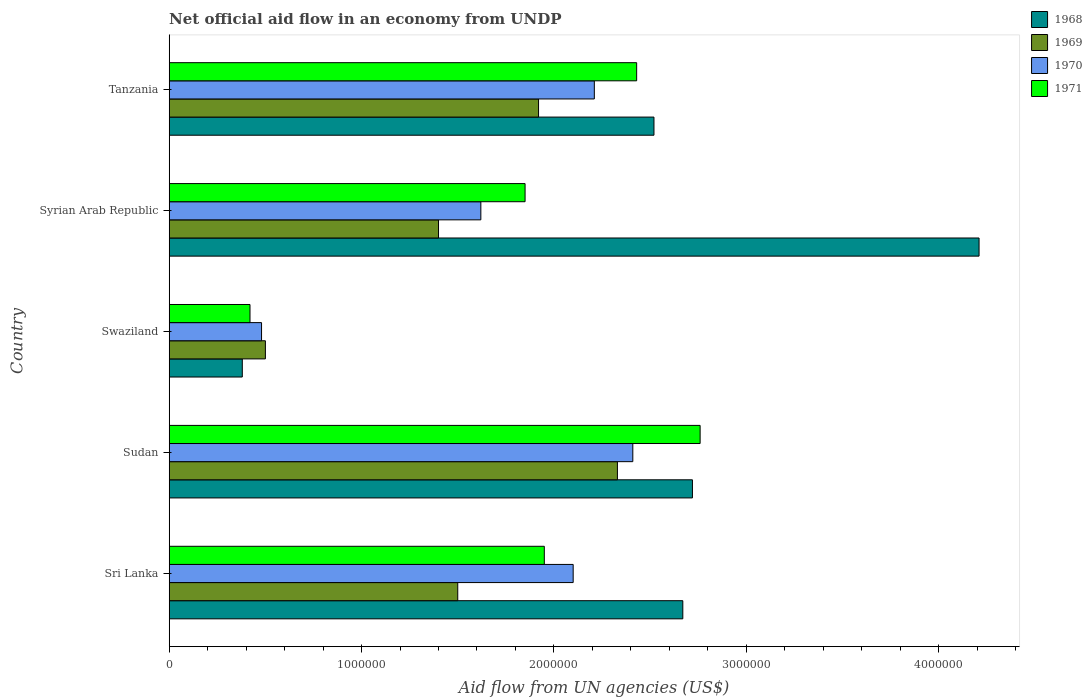How many different coloured bars are there?
Provide a short and direct response. 4. How many groups of bars are there?
Your answer should be very brief. 5. Are the number of bars per tick equal to the number of legend labels?
Offer a very short reply. Yes. Are the number of bars on each tick of the Y-axis equal?
Your answer should be compact. Yes. How many bars are there on the 1st tick from the top?
Provide a succinct answer. 4. What is the label of the 4th group of bars from the top?
Give a very brief answer. Sudan. What is the net official aid flow in 1970 in Tanzania?
Your response must be concise. 2.21e+06. Across all countries, what is the maximum net official aid flow in 1968?
Ensure brevity in your answer.  4.21e+06. Across all countries, what is the minimum net official aid flow in 1969?
Keep it short and to the point. 5.00e+05. In which country was the net official aid flow in 1970 maximum?
Your answer should be compact. Sudan. In which country was the net official aid flow in 1969 minimum?
Provide a succinct answer. Swaziland. What is the total net official aid flow in 1969 in the graph?
Ensure brevity in your answer.  7.65e+06. What is the difference between the net official aid flow in 1971 in Syrian Arab Republic and that in Tanzania?
Ensure brevity in your answer.  -5.80e+05. What is the difference between the net official aid flow in 1970 in Tanzania and the net official aid flow in 1971 in Swaziland?
Keep it short and to the point. 1.79e+06. What is the average net official aid flow in 1970 per country?
Your answer should be compact. 1.76e+06. What is the difference between the net official aid flow in 1968 and net official aid flow in 1969 in Syrian Arab Republic?
Offer a very short reply. 2.81e+06. In how many countries, is the net official aid flow in 1968 greater than 1600000 US$?
Make the answer very short. 4. What is the ratio of the net official aid flow in 1968 in Sri Lanka to that in Syrian Arab Republic?
Your response must be concise. 0.63. Is the net official aid flow in 1969 in Sri Lanka less than that in Swaziland?
Provide a short and direct response. No. Is the difference between the net official aid flow in 1968 in Sudan and Tanzania greater than the difference between the net official aid flow in 1969 in Sudan and Tanzania?
Provide a short and direct response. No. What is the difference between the highest and the second highest net official aid flow in 1970?
Give a very brief answer. 2.00e+05. What is the difference between the highest and the lowest net official aid flow in 1969?
Offer a very short reply. 1.83e+06. In how many countries, is the net official aid flow in 1971 greater than the average net official aid flow in 1971 taken over all countries?
Provide a succinct answer. 3. Is the sum of the net official aid flow in 1969 in Sri Lanka and Swaziland greater than the maximum net official aid flow in 1971 across all countries?
Offer a terse response. No. Is it the case that in every country, the sum of the net official aid flow in 1971 and net official aid flow in 1969 is greater than the sum of net official aid flow in 1968 and net official aid flow in 1970?
Your response must be concise. No. What does the 1st bar from the bottom in Sri Lanka represents?
Provide a short and direct response. 1968. How many countries are there in the graph?
Provide a short and direct response. 5. What is the difference between two consecutive major ticks on the X-axis?
Offer a terse response. 1.00e+06. Does the graph contain any zero values?
Provide a short and direct response. No. How many legend labels are there?
Your answer should be compact. 4. What is the title of the graph?
Give a very brief answer. Net official aid flow in an economy from UNDP. Does "1978" appear as one of the legend labels in the graph?
Provide a succinct answer. No. What is the label or title of the X-axis?
Offer a terse response. Aid flow from UN agencies (US$). What is the Aid flow from UN agencies (US$) in 1968 in Sri Lanka?
Give a very brief answer. 2.67e+06. What is the Aid flow from UN agencies (US$) of 1969 in Sri Lanka?
Offer a very short reply. 1.50e+06. What is the Aid flow from UN agencies (US$) in 1970 in Sri Lanka?
Offer a terse response. 2.10e+06. What is the Aid flow from UN agencies (US$) of 1971 in Sri Lanka?
Make the answer very short. 1.95e+06. What is the Aid flow from UN agencies (US$) in 1968 in Sudan?
Give a very brief answer. 2.72e+06. What is the Aid flow from UN agencies (US$) in 1969 in Sudan?
Your answer should be very brief. 2.33e+06. What is the Aid flow from UN agencies (US$) in 1970 in Sudan?
Ensure brevity in your answer.  2.41e+06. What is the Aid flow from UN agencies (US$) in 1971 in Sudan?
Keep it short and to the point. 2.76e+06. What is the Aid flow from UN agencies (US$) in 1968 in Swaziland?
Provide a short and direct response. 3.80e+05. What is the Aid flow from UN agencies (US$) of 1969 in Swaziland?
Your response must be concise. 5.00e+05. What is the Aid flow from UN agencies (US$) of 1970 in Swaziland?
Your response must be concise. 4.80e+05. What is the Aid flow from UN agencies (US$) of 1971 in Swaziland?
Provide a short and direct response. 4.20e+05. What is the Aid flow from UN agencies (US$) of 1968 in Syrian Arab Republic?
Offer a terse response. 4.21e+06. What is the Aid flow from UN agencies (US$) in 1969 in Syrian Arab Republic?
Your answer should be very brief. 1.40e+06. What is the Aid flow from UN agencies (US$) of 1970 in Syrian Arab Republic?
Make the answer very short. 1.62e+06. What is the Aid flow from UN agencies (US$) of 1971 in Syrian Arab Republic?
Provide a succinct answer. 1.85e+06. What is the Aid flow from UN agencies (US$) of 1968 in Tanzania?
Offer a very short reply. 2.52e+06. What is the Aid flow from UN agencies (US$) of 1969 in Tanzania?
Your answer should be compact. 1.92e+06. What is the Aid flow from UN agencies (US$) in 1970 in Tanzania?
Provide a short and direct response. 2.21e+06. What is the Aid flow from UN agencies (US$) in 1971 in Tanzania?
Your response must be concise. 2.43e+06. Across all countries, what is the maximum Aid flow from UN agencies (US$) in 1968?
Give a very brief answer. 4.21e+06. Across all countries, what is the maximum Aid flow from UN agencies (US$) in 1969?
Ensure brevity in your answer.  2.33e+06. Across all countries, what is the maximum Aid flow from UN agencies (US$) of 1970?
Your answer should be compact. 2.41e+06. Across all countries, what is the maximum Aid flow from UN agencies (US$) in 1971?
Your answer should be compact. 2.76e+06. Across all countries, what is the minimum Aid flow from UN agencies (US$) of 1968?
Provide a short and direct response. 3.80e+05. Across all countries, what is the minimum Aid flow from UN agencies (US$) of 1970?
Ensure brevity in your answer.  4.80e+05. Across all countries, what is the minimum Aid flow from UN agencies (US$) in 1971?
Offer a terse response. 4.20e+05. What is the total Aid flow from UN agencies (US$) of 1968 in the graph?
Make the answer very short. 1.25e+07. What is the total Aid flow from UN agencies (US$) in 1969 in the graph?
Offer a very short reply. 7.65e+06. What is the total Aid flow from UN agencies (US$) in 1970 in the graph?
Your response must be concise. 8.82e+06. What is the total Aid flow from UN agencies (US$) of 1971 in the graph?
Offer a very short reply. 9.41e+06. What is the difference between the Aid flow from UN agencies (US$) in 1969 in Sri Lanka and that in Sudan?
Your response must be concise. -8.30e+05. What is the difference between the Aid flow from UN agencies (US$) of 1970 in Sri Lanka and that in Sudan?
Ensure brevity in your answer.  -3.10e+05. What is the difference between the Aid flow from UN agencies (US$) of 1971 in Sri Lanka and that in Sudan?
Give a very brief answer. -8.10e+05. What is the difference between the Aid flow from UN agencies (US$) in 1968 in Sri Lanka and that in Swaziland?
Give a very brief answer. 2.29e+06. What is the difference between the Aid flow from UN agencies (US$) in 1969 in Sri Lanka and that in Swaziland?
Your answer should be compact. 1.00e+06. What is the difference between the Aid flow from UN agencies (US$) in 1970 in Sri Lanka and that in Swaziland?
Provide a short and direct response. 1.62e+06. What is the difference between the Aid flow from UN agencies (US$) in 1971 in Sri Lanka and that in Swaziland?
Ensure brevity in your answer.  1.53e+06. What is the difference between the Aid flow from UN agencies (US$) of 1968 in Sri Lanka and that in Syrian Arab Republic?
Keep it short and to the point. -1.54e+06. What is the difference between the Aid flow from UN agencies (US$) in 1971 in Sri Lanka and that in Syrian Arab Republic?
Your answer should be very brief. 1.00e+05. What is the difference between the Aid flow from UN agencies (US$) in 1969 in Sri Lanka and that in Tanzania?
Offer a very short reply. -4.20e+05. What is the difference between the Aid flow from UN agencies (US$) of 1971 in Sri Lanka and that in Tanzania?
Provide a short and direct response. -4.80e+05. What is the difference between the Aid flow from UN agencies (US$) of 1968 in Sudan and that in Swaziland?
Your answer should be very brief. 2.34e+06. What is the difference between the Aid flow from UN agencies (US$) of 1969 in Sudan and that in Swaziland?
Your response must be concise. 1.83e+06. What is the difference between the Aid flow from UN agencies (US$) of 1970 in Sudan and that in Swaziland?
Provide a short and direct response. 1.93e+06. What is the difference between the Aid flow from UN agencies (US$) of 1971 in Sudan and that in Swaziland?
Your response must be concise. 2.34e+06. What is the difference between the Aid flow from UN agencies (US$) in 1968 in Sudan and that in Syrian Arab Republic?
Provide a succinct answer. -1.49e+06. What is the difference between the Aid flow from UN agencies (US$) of 1969 in Sudan and that in Syrian Arab Republic?
Your answer should be very brief. 9.30e+05. What is the difference between the Aid flow from UN agencies (US$) of 1970 in Sudan and that in Syrian Arab Republic?
Offer a terse response. 7.90e+05. What is the difference between the Aid flow from UN agencies (US$) of 1971 in Sudan and that in Syrian Arab Republic?
Your answer should be very brief. 9.10e+05. What is the difference between the Aid flow from UN agencies (US$) of 1968 in Sudan and that in Tanzania?
Provide a short and direct response. 2.00e+05. What is the difference between the Aid flow from UN agencies (US$) in 1971 in Sudan and that in Tanzania?
Offer a terse response. 3.30e+05. What is the difference between the Aid flow from UN agencies (US$) in 1968 in Swaziland and that in Syrian Arab Republic?
Provide a short and direct response. -3.83e+06. What is the difference between the Aid flow from UN agencies (US$) in 1969 in Swaziland and that in Syrian Arab Republic?
Your answer should be compact. -9.00e+05. What is the difference between the Aid flow from UN agencies (US$) of 1970 in Swaziland and that in Syrian Arab Republic?
Ensure brevity in your answer.  -1.14e+06. What is the difference between the Aid flow from UN agencies (US$) in 1971 in Swaziland and that in Syrian Arab Republic?
Your response must be concise. -1.43e+06. What is the difference between the Aid flow from UN agencies (US$) in 1968 in Swaziland and that in Tanzania?
Ensure brevity in your answer.  -2.14e+06. What is the difference between the Aid flow from UN agencies (US$) in 1969 in Swaziland and that in Tanzania?
Keep it short and to the point. -1.42e+06. What is the difference between the Aid flow from UN agencies (US$) in 1970 in Swaziland and that in Tanzania?
Your answer should be compact. -1.73e+06. What is the difference between the Aid flow from UN agencies (US$) of 1971 in Swaziland and that in Tanzania?
Ensure brevity in your answer.  -2.01e+06. What is the difference between the Aid flow from UN agencies (US$) in 1968 in Syrian Arab Republic and that in Tanzania?
Your answer should be compact. 1.69e+06. What is the difference between the Aid flow from UN agencies (US$) of 1969 in Syrian Arab Republic and that in Tanzania?
Offer a terse response. -5.20e+05. What is the difference between the Aid flow from UN agencies (US$) in 1970 in Syrian Arab Republic and that in Tanzania?
Your answer should be very brief. -5.90e+05. What is the difference between the Aid flow from UN agencies (US$) of 1971 in Syrian Arab Republic and that in Tanzania?
Your answer should be very brief. -5.80e+05. What is the difference between the Aid flow from UN agencies (US$) of 1968 in Sri Lanka and the Aid flow from UN agencies (US$) of 1969 in Sudan?
Ensure brevity in your answer.  3.40e+05. What is the difference between the Aid flow from UN agencies (US$) of 1968 in Sri Lanka and the Aid flow from UN agencies (US$) of 1970 in Sudan?
Keep it short and to the point. 2.60e+05. What is the difference between the Aid flow from UN agencies (US$) in 1969 in Sri Lanka and the Aid flow from UN agencies (US$) in 1970 in Sudan?
Your answer should be compact. -9.10e+05. What is the difference between the Aid flow from UN agencies (US$) of 1969 in Sri Lanka and the Aid flow from UN agencies (US$) of 1971 in Sudan?
Ensure brevity in your answer.  -1.26e+06. What is the difference between the Aid flow from UN agencies (US$) of 1970 in Sri Lanka and the Aid flow from UN agencies (US$) of 1971 in Sudan?
Make the answer very short. -6.60e+05. What is the difference between the Aid flow from UN agencies (US$) of 1968 in Sri Lanka and the Aid flow from UN agencies (US$) of 1969 in Swaziland?
Give a very brief answer. 2.17e+06. What is the difference between the Aid flow from UN agencies (US$) in 1968 in Sri Lanka and the Aid flow from UN agencies (US$) in 1970 in Swaziland?
Provide a short and direct response. 2.19e+06. What is the difference between the Aid flow from UN agencies (US$) of 1968 in Sri Lanka and the Aid flow from UN agencies (US$) of 1971 in Swaziland?
Ensure brevity in your answer.  2.25e+06. What is the difference between the Aid flow from UN agencies (US$) of 1969 in Sri Lanka and the Aid flow from UN agencies (US$) of 1970 in Swaziland?
Ensure brevity in your answer.  1.02e+06. What is the difference between the Aid flow from UN agencies (US$) in 1969 in Sri Lanka and the Aid flow from UN agencies (US$) in 1971 in Swaziland?
Offer a very short reply. 1.08e+06. What is the difference between the Aid flow from UN agencies (US$) in 1970 in Sri Lanka and the Aid flow from UN agencies (US$) in 1971 in Swaziland?
Provide a succinct answer. 1.68e+06. What is the difference between the Aid flow from UN agencies (US$) in 1968 in Sri Lanka and the Aid flow from UN agencies (US$) in 1969 in Syrian Arab Republic?
Make the answer very short. 1.27e+06. What is the difference between the Aid flow from UN agencies (US$) in 1968 in Sri Lanka and the Aid flow from UN agencies (US$) in 1970 in Syrian Arab Republic?
Offer a terse response. 1.05e+06. What is the difference between the Aid flow from UN agencies (US$) of 1968 in Sri Lanka and the Aid flow from UN agencies (US$) of 1971 in Syrian Arab Republic?
Your answer should be compact. 8.20e+05. What is the difference between the Aid flow from UN agencies (US$) in 1969 in Sri Lanka and the Aid flow from UN agencies (US$) in 1971 in Syrian Arab Republic?
Offer a terse response. -3.50e+05. What is the difference between the Aid flow from UN agencies (US$) in 1968 in Sri Lanka and the Aid flow from UN agencies (US$) in 1969 in Tanzania?
Make the answer very short. 7.50e+05. What is the difference between the Aid flow from UN agencies (US$) in 1968 in Sri Lanka and the Aid flow from UN agencies (US$) in 1971 in Tanzania?
Ensure brevity in your answer.  2.40e+05. What is the difference between the Aid flow from UN agencies (US$) in 1969 in Sri Lanka and the Aid flow from UN agencies (US$) in 1970 in Tanzania?
Keep it short and to the point. -7.10e+05. What is the difference between the Aid flow from UN agencies (US$) in 1969 in Sri Lanka and the Aid flow from UN agencies (US$) in 1971 in Tanzania?
Provide a short and direct response. -9.30e+05. What is the difference between the Aid flow from UN agencies (US$) in 1970 in Sri Lanka and the Aid flow from UN agencies (US$) in 1971 in Tanzania?
Keep it short and to the point. -3.30e+05. What is the difference between the Aid flow from UN agencies (US$) in 1968 in Sudan and the Aid flow from UN agencies (US$) in 1969 in Swaziland?
Provide a succinct answer. 2.22e+06. What is the difference between the Aid flow from UN agencies (US$) of 1968 in Sudan and the Aid flow from UN agencies (US$) of 1970 in Swaziland?
Provide a short and direct response. 2.24e+06. What is the difference between the Aid flow from UN agencies (US$) in 1968 in Sudan and the Aid flow from UN agencies (US$) in 1971 in Swaziland?
Provide a short and direct response. 2.30e+06. What is the difference between the Aid flow from UN agencies (US$) in 1969 in Sudan and the Aid flow from UN agencies (US$) in 1970 in Swaziland?
Ensure brevity in your answer.  1.85e+06. What is the difference between the Aid flow from UN agencies (US$) of 1969 in Sudan and the Aid flow from UN agencies (US$) of 1971 in Swaziland?
Keep it short and to the point. 1.91e+06. What is the difference between the Aid flow from UN agencies (US$) in 1970 in Sudan and the Aid flow from UN agencies (US$) in 1971 in Swaziland?
Ensure brevity in your answer.  1.99e+06. What is the difference between the Aid flow from UN agencies (US$) of 1968 in Sudan and the Aid flow from UN agencies (US$) of 1969 in Syrian Arab Republic?
Offer a terse response. 1.32e+06. What is the difference between the Aid flow from UN agencies (US$) of 1968 in Sudan and the Aid flow from UN agencies (US$) of 1970 in Syrian Arab Republic?
Ensure brevity in your answer.  1.10e+06. What is the difference between the Aid flow from UN agencies (US$) of 1968 in Sudan and the Aid flow from UN agencies (US$) of 1971 in Syrian Arab Republic?
Make the answer very short. 8.70e+05. What is the difference between the Aid flow from UN agencies (US$) of 1969 in Sudan and the Aid flow from UN agencies (US$) of 1970 in Syrian Arab Republic?
Provide a succinct answer. 7.10e+05. What is the difference between the Aid flow from UN agencies (US$) of 1969 in Sudan and the Aid flow from UN agencies (US$) of 1971 in Syrian Arab Republic?
Your answer should be very brief. 4.80e+05. What is the difference between the Aid flow from UN agencies (US$) of 1970 in Sudan and the Aid flow from UN agencies (US$) of 1971 in Syrian Arab Republic?
Your answer should be compact. 5.60e+05. What is the difference between the Aid flow from UN agencies (US$) of 1968 in Sudan and the Aid flow from UN agencies (US$) of 1969 in Tanzania?
Provide a succinct answer. 8.00e+05. What is the difference between the Aid flow from UN agencies (US$) in 1968 in Sudan and the Aid flow from UN agencies (US$) in 1970 in Tanzania?
Your answer should be compact. 5.10e+05. What is the difference between the Aid flow from UN agencies (US$) in 1968 in Swaziland and the Aid flow from UN agencies (US$) in 1969 in Syrian Arab Republic?
Offer a terse response. -1.02e+06. What is the difference between the Aid flow from UN agencies (US$) of 1968 in Swaziland and the Aid flow from UN agencies (US$) of 1970 in Syrian Arab Republic?
Offer a very short reply. -1.24e+06. What is the difference between the Aid flow from UN agencies (US$) of 1968 in Swaziland and the Aid flow from UN agencies (US$) of 1971 in Syrian Arab Republic?
Your answer should be compact. -1.47e+06. What is the difference between the Aid flow from UN agencies (US$) of 1969 in Swaziland and the Aid flow from UN agencies (US$) of 1970 in Syrian Arab Republic?
Keep it short and to the point. -1.12e+06. What is the difference between the Aid flow from UN agencies (US$) in 1969 in Swaziland and the Aid flow from UN agencies (US$) in 1971 in Syrian Arab Republic?
Provide a short and direct response. -1.35e+06. What is the difference between the Aid flow from UN agencies (US$) of 1970 in Swaziland and the Aid flow from UN agencies (US$) of 1971 in Syrian Arab Republic?
Provide a short and direct response. -1.37e+06. What is the difference between the Aid flow from UN agencies (US$) of 1968 in Swaziland and the Aid flow from UN agencies (US$) of 1969 in Tanzania?
Offer a very short reply. -1.54e+06. What is the difference between the Aid flow from UN agencies (US$) of 1968 in Swaziland and the Aid flow from UN agencies (US$) of 1970 in Tanzania?
Your response must be concise. -1.83e+06. What is the difference between the Aid flow from UN agencies (US$) in 1968 in Swaziland and the Aid flow from UN agencies (US$) in 1971 in Tanzania?
Provide a short and direct response. -2.05e+06. What is the difference between the Aid flow from UN agencies (US$) in 1969 in Swaziland and the Aid flow from UN agencies (US$) in 1970 in Tanzania?
Ensure brevity in your answer.  -1.71e+06. What is the difference between the Aid flow from UN agencies (US$) of 1969 in Swaziland and the Aid flow from UN agencies (US$) of 1971 in Tanzania?
Provide a succinct answer. -1.93e+06. What is the difference between the Aid flow from UN agencies (US$) of 1970 in Swaziland and the Aid flow from UN agencies (US$) of 1971 in Tanzania?
Your response must be concise. -1.95e+06. What is the difference between the Aid flow from UN agencies (US$) in 1968 in Syrian Arab Republic and the Aid flow from UN agencies (US$) in 1969 in Tanzania?
Give a very brief answer. 2.29e+06. What is the difference between the Aid flow from UN agencies (US$) in 1968 in Syrian Arab Republic and the Aid flow from UN agencies (US$) in 1970 in Tanzania?
Provide a short and direct response. 2.00e+06. What is the difference between the Aid flow from UN agencies (US$) in 1968 in Syrian Arab Republic and the Aid flow from UN agencies (US$) in 1971 in Tanzania?
Offer a terse response. 1.78e+06. What is the difference between the Aid flow from UN agencies (US$) of 1969 in Syrian Arab Republic and the Aid flow from UN agencies (US$) of 1970 in Tanzania?
Ensure brevity in your answer.  -8.10e+05. What is the difference between the Aid flow from UN agencies (US$) of 1969 in Syrian Arab Republic and the Aid flow from UN agencies (US$) of 1971 in Tanzania?
Make the answer very short. -1.03e+06. What is the difference between the Aid flow from UN agencies (US$) in 1970 in Syrian Arab Republic and the Aid flow from UN agencies (US$) in 1971 in Tanzania?
Make the answer very short. -8.10e+05. What is the average Aid flow from UN agencies (US$) in 1968 per country?
Make the answer very short. 2.50e+06. What is the average Aid flow from UN agencies (US$) in 1969 per country?
Offer a terse response. 1.53e+06. What is the average Aid flow from UN agencies (US$) in 1970 per country?
Keep it short and to the point. 1.76e+06. What is the average Aid flow from UN agencies (US$) of 1971 per country?
Your answer should be compact. 1.88e+06. What is the difference between the Aid flow from UN agencies (US$) in 1968 and Aid flow from UN agencies (US$) in 1969 in Sri Lanka?
Provide a short and direct response. 1.17e+06. What is the difference between the Aid flow from UN agencies (US$) in 1968 and Aid flow from UN agencies (US$) in 1970 in Sri Lanka?
Your answer should be compact. 5.70e+05. What is the difference between the Aid flow from UN agencies (US$) of 1968 and Aid flow from UN agencies (US$) of 1971 in Sri Lanka?
Make the answer very short. 7.20e+05. What is the difference between the Aid flow from UN agencies (US$) of 1969 and Aid flow from UN agencies (US$) of 1970 in Sri Lanka?
Your answer should be compact. -6.00e+05. What is the difference between the Aid flow from UN agencies (US$) of 1969 and Aid flow from UN agencies (US$) of 1971 in Sri Lanka?
Your answer should be compact. -4.50e+05. What is the difference between the Aid flow from UN agencies (US$) of 1970 and Aid flow from UN agencies (US$) of 1971 in Sri Lanka?
Your response must be concise. 1.50e+05. What is the difference between the Aid flow from UN agencies (US$) of 1968 and Aid flow from UN agencies (US$) of 1970 in Sudan?
Your answer should be very brief. 3.10e+05. What is the difference between the Aid flow from UN agencies (US$) of 1968 and Aid flow from UN agencies (US$) of 1971 in Sudan?
Your response must be concise. -4.00e+04. What is the difference between the Aid flow from UN agencies (US$) in 1969 and Aid flow from UN agencies (US$) in 1970 in Sudan?
Offer a very short reply. -8.00e+04. What is the difference between the Aid flow from UN agencies (US$) in 1969 and Aid flow from UN agencies (US$) in 1971 in Sudan?
Make the answer very short. -4.30e+05. What is the difference between the Aid flow from UN agencies (US$) in 1970 and Aid flow from UN agencies (US$) in 1971 in Sudan?
Keep it short and to the point. -3.50e+05. What is the difference between the Aid flow from UN agencies (US$) of 1968 and Aid flow from UN agencies (US$) of 1971 in Swaziland?
Your answer should be compact. -4.00e+04. What is the difference between the Aid flow from UN agencies (US$) in 1969 and Aid flow from UN agencies (US$) in 1970 in Swaziland?
Provide a succinct answer. 2.00e+04. What is the difference between the Aid flow from UN agencies (US$) in 1970 and Aid flow from UN agencies (US$) in 1971 in Swaziland?
Provide a short and direct response. 6.00e+04. What is the difference between the Aid flow from UN agencies (US$) in 1968 and Aid flow from UN agencies (US$) in 1969 in Syrian Arab Republic?
Provide a succinct answer. 2.81e+06. What is the difference between the Aid flow from UN agencies (US$) of 1968 and Aid flow from UN agencies (US$) of 1970 in Syrian Arab Republic?
Ensure brevity in your answer.  2.59e+06. What is the difference between the Aid flow from UN agencies (US$) of 1968 and Aid flow from UN agencies (US$) of 1971 in Syrian Arab Republic?
Provide a short and direct response. 2.36e+06. What is the difference between the Aid flow from UN agencies (US$) of 1969 and Aid flow from UN agencies (US$) of 1970 in Syrian Arab Republic?
Provide a short and direct response. -2.20e+05. What is the difference between the Aid flow from UN agencies (US$) in 1969 and Aid flow from UN agencies (US$) in 1971 in Syrian Arab Republic?
Give a very brief answer. -4.50e+05. What is the difference between the Aid flow from UN agencies (US$) of 1970 and Aid flow from UN agencies (US$) of 1971 in Syrian Arab Republic?
Give a very brief answer. -2.30e+05. What is the difference between the Aid flow from UN agencies (US$) of 1968 and Aid flow from UN agencies (US$) of 1969 in Tanzania?
Give a very brief answer. 6.00e+05. What is the difference between the Aid flow from UN agencies (US$) of 1968 and Aid flow from UN agencies (US$) of 1970 in Tanzania?
Keep it short and to the point. 3.10e+05. What is the difference between the Aid flow from UN agencies (US$) of 1969 and Aid flow from UN agencies (US$) of 1971 in Tanzania?
Your answer should be compact. -5.10e+05. What is the ratio of the Aid flow from UN agencies (US$) in 1968 in Sri Lanka to that in Sudan?
Ensure brevity in your answer.  0.98. What is the ratio of the Aid flow from UN agencies (US$) in 1969 in Sri Lanka to that in Sudan?
Offer a terse response. 0.64. What is the ratio of the Aid flow from UN agencies (US$) of 1970 in Sri Lanka to that in Sudan?
Provide a succinct answer. 0.87. What is the ratio of the Aid flow from UN agencies (US$) in 1971 in Sri Lanka to that in Sudan?
Offer a terse response. 0.71. What is the ratio of the Aid flow from UN agencies (US$) in 1968 in Sri Lanka to that in Swaziland?
Ensure brevity in your answer.  7.03. What is the ratio of the Aid flow from UN agencies (US$) in 1969 in Sri Lanka to that in Swaziland?
Give a very brief answer. 3. What is the ratio of the Aid flow from UN agencies (US$) of 1970 in Sri Lanka to that in Swaziland?
Keep it short and to the point. 4.38. What is the ratio of the Aid flow from UN agencies (US$) in 1971 in Sri Lanka to that in Swaziland?
Provide a short and direct response. 4.64. What is the ratio of the Aid flow from UN agencies (US$) in 1968 in Sri Lanka to that in Syrian Arab Republic?
Provide a short and direct response. 0.63. What is the ratio of the Aid flow from UN agencies (US$) in 1969 in Sri Lanka to that in Syrian Arab Republic?
Your answer should be very brief. 1.07. What is the ratio of the Aid flow from UN agencies (US$) of 1970 in Sri Lanka to that in Syrian Arab Republic?
Provide a short and direct response. 1.3. What is the ratio of the Aid flow from UN agencies (US$) in 1971 in Sri Lanka to that in Syrian Arab Republic?
Your response must be concise. 1.05. What is the ratio of the Aid flow from UN agencies (US$) in 1968 in Sri Lanka to that in Tanzania?
Your response must be concise. 1.06. What is the ratio of the Aid flow from UN agencies (US$) of 1969 in Sri Lanka to that in Tanzania?
Make the answer very short. 0.78. What is the ratio of the Aid flow from UN agencies (US$) of 1970 in Sri Lanka to that in Tanzania?
Make the answer very short. 0.95. What is the ratio of the Aid flow from UN agencies (US$) in 1971 in Sri Lanka to that in Tanzania?
Keep it short and to the point. 0.8. What is the ratio of the Aid flow from UN agencies (US$) of 1968 in Sudan to that in Swaziland?
Ensure brevity in your answer.  7.16. What is the ratio of the Aid flow from UN agencies (US$) of 1969 in Sudan to that in Swaziland?
Provide a succinct answer. 4.66. What is the ratio of the Aid flow from UN agencies (US$) in 1970 in Sudan to that in Swaziland?
Make the answer very short. 5.02. What is the ratio of the Aid flow from UN agencies (US$) of 1971 in Sudan to that in Swaziland?
Provide a succinct answer. 6.57. What is the ratio of the Aid flow from UN agencies (US$) of 1968 in Sudan to that in Syrian Arab Republic?
Ensure brevity in your answer.  0.65. What is the ratio of the Aid flow from UN agencies (US$) of 1969 in Sudan to that in Syrian Arab Republic?
Your response must be concise. 1.66. What is the ratio of the Aid flow from UN agencies (US$) of 1970 in Sudan to that in Syrian Arab Republic?
Keep it short and to the point. 1.49. What is the ratio of the Aid flow from UN agencies (US$) in 1971 in Sudan to that in Syrian Arab Republic?
Your answer should be very brief. 1.49. What is the ratio of the Aid flow from UN agencies (US$) in 1968 in Sudan to that in Tanzania?
Give a very brief answer. 1.08. What is the ratio of the Aid flow from UN agencies (US$) in 1969 in Sudan to that in Tanzania?
Provide a succinct answer. 1.21. What is the ratio of the Aid flow from UN agencies (US$) of 1970 in Sudan to that in Tanzania?
Give a very brief answer. 1.09. What is the ratio of the Aid flow from UN agencies (US$) of 1971 in Sudan to that in Tanzania?
Ensure brevity in your answer.  1.14. What is the ratio of the Aid flow from UN agencies (US$) of 1968 in Swaziland to that in Syrian Arab Republic?
Give a very brief answer. 0.09. What is the ratio of the Aid flow from UN agencies (US$) in 1969 in Swaziland to that in Syrian Arab Republic?
Keep it short and to the point. 0.36. What is the ratio of the Aid flow from UN agencies (US$) in 1970 in Swaziland to that in Syrian Arab Republic?
Provide a succinct answer. 0.3. What is the ratio of the Aid flow from UN agencies (US$) in 1971 in Swaziland to that in Syrian Arab Republic?
Ensure brevity in your answer.  0.23. What is the ratio of the Aid flow from UN agencies (US$) in 1968 in Swaziland to that in Tanzania?
Your response must be concise. 0.15. What is the ratio of the Aid flow from UN agencies (US$) of 1969 in Swaziland to that in Tanzania?
Ensure brevity in your answer.  0.26. What is the ratio of the Aid flow from UN agencies (US$) in 1970 in Swaziland to that in Tanzania?
Ensure brevity in your answer.  0.22. What is the ratio of the Aid flow from UN agencies (US$) in 1971 in Swaziland to that in Tanzania?
Make the answer very short. 0.17. What is the ratio of the Aid flow from UN agencies (US$) in 1968 in Syrian Arab Republic to that in Tanzania?
Give a very brief answer. 1.67. What is the ratio of the Aid flow from UN agencies (US$) of 1969 in Syrian Arab Republic to that in Tanzania?
Your response must be concise. 0.73. What is the ratio of the Aid flow from UN agencies (US$) of 1970 in Syrian Arab Republic to that in Tanzania?
Make the answer very short. 0.73. What is the ratio of the Aid flow from UN agencies (US$) of 1971 in Syrian Arab Republic to that in Tanzania?
Your answer should be very brief. 0.76. What is the difference between the highest and the second highest Aid flow from UN agencies (US$) of 1968?
Your answer should be very brief. 1.49e+06. What is the difference between the highest and the lowest Aid flow from UN agencies (US$) of 1968?
Your answer should be compact. 3.83e+06. What is the difference between the highest and the lowest Aid flow from UN agencies (US$) of 1969?
Keep it short and to the point. 1.83e+06. What is the difference between the highest and the lowest Aid flow from UN agencies (US$) in 1970?
Ensure brevity in your answer.  1.93e+06. What is the difference between the highest and the lowest Aid flow from UN agencies (US$) in 1971?
Offer a terse response. 2.34e+06. 